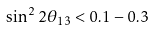<formula> <loc_0><loc_0><loc_500><loc_500>\sin ^ { 2 } 2 \theta _ { 1 3 } < 0 . 1 - 0 . 3</formula> 